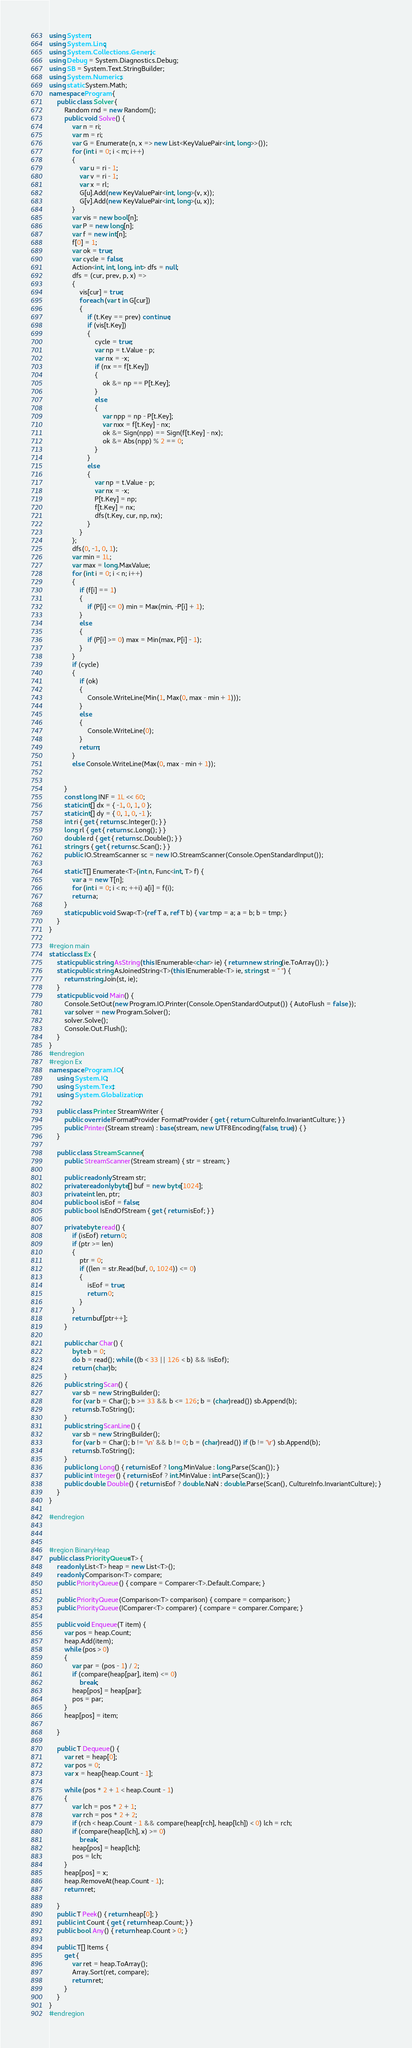<code> <loc_0><loc_0><loc_500><loc_500><_C#_>using System;
using System.Linq;
using System.Collections.Generic;
using Debug = System.Diagnostics.Debug;
using SB = System.Text.StringBuilder;
using System.Numerics;
using static System.Math;
namespace Program {
    public class Solver {
        Random rnd = new Random();
        public void Solve() {
            var n = ri;
            var m = ri;
            var G = Enumerate(n, x => new List<KeyValuePair<int, long>>());
            for (int i = 0; i < m; i++)
            {
                var u = ri - 1;
                var v = ri - 1;
                var x = rl;
                G[u].Add(new KeyValuePair<int, long>(v, x));
                G[v].Add(new KeyValuePair<int, long>(u, x));
            }
            var vis = new bool[n];
            var P = new long[n];
            var f = new int[n];
            f[0] = 1;
            var ok = true;
            var cycle = false;
            Action<int, int, long, int> dfs = null;
            dfs = (cur, prev, p, x) =>
            {
                vis[cur] = true;
                foreach (var t in G[cur])
                {
                    if (t.Key == prev) continue;
                    if (vis[t.Key])
                    {
                        cycle = true;
                        var np = t.Value - p;
                        var nx = -x;
                        if (nx == f[t.Key])
                        {
                            ok &= np == P[t.Key];
                        }
                        else
                        {
                            var npp = np - P[t.Key];
                            var nxx = f[t.Key] - nx;
                            ok &= Sign(npp) == Sign(f[t.Key] - nx);
                            ok &= Abs(npp) % 2 == 0;
                        }
                    }
                    else
                    {
                        var np = t.Value - p;
                        var nx = -x;
                        P[t.Key] = np;
                        f[t.Key] = nx;
                        dfs(t.Key, cur, np, nx);
                    }
                }
            };
            dfs(0, -1, 0, 1);
            var min = 1L;
            var max = long.MaxValue;
            for (int i = 0; i < n; i++)
            {
                if (f[i] == 1)
                {
                    if (P[i] <= 0) min = Max(min, -P[i] + 1);
                }
                else
                {
                    if (P[i] >= 0) max = Min(max, P[i] - 1);
                }
            }
            if (cycle)
            {
                if (ok)
                {
                    Console.WriteLine(Min(1, Max(0, max - min + 1)));
                }
                else
                {
                    Console.WriteLine(0);
                }
                return;
            }
            else Console.WriteLine(Max(0, max - min + 1));


        }
        const long INF = 1L << 60;
        static int[] dx = { -1, 0, 1, 0 };
        static int[] dy = { 0, 1, 0, -1 };
        int ri { get { return sc.Integer(); } }
        long rl { get { return sc.Long(); } }
        double rd { get { return sc.Double(); } }
        string rs { get { return sc.Scan(); } }
        public IO.StreamScanner sc = new IO.StreamScanner(Console.OpenStandardInput());

        static T[] Enumerate<T>(int n, Func<int, T> f) {
            var a = new T[n];
            for (int i = 0; i < n; ++i) a[i] = f(i);
            return a;
        }
        static public void Swap<T>(ref T a, ref T b) { var tmp = a; a = b; b = tmp; }
    }
}

#region main
static class Ex {
    static public string AsString(this IEnumerable<char> ie) { return new string(ie.ToArray()); }
    static public string AsJoinedString<T>(this IEnumerable<T> ie, string st = " ") {
        return string.Join(st, ie);
    }
    static public void Main() {
        Console.SetOut(new Program.IO.Printer(Console.OpenStandardOutput()) { AutoFlush = false });
        var solver = new Program.Solver();
        solver.Solve();
        Console.Out.Flush();
    }
}
#endregion
#region Ex
namespace Program.IO {
    using System.IO;
    using System.Text;
    using System.Globalization;

    public class Printer: StreamWriter {
        public override IFormatProvider FormatProvider { get { return CultureInfo.InvariantCulture; } }
        public Printer(Stream stream) : base(stream, new UTF8Encoding(false, true)) { }
    }

    public class StreamScanner {
        public StreamScanner(Stream stream) { str = stream; }

        public readonly Stream str;
        private readonly byte[] buf = new byte[1024];
        private int len, ptr;
        public bool isEof = false;
        public bool IsEndOfStream { get { return isEof; } }

        private byte read() {
            if (isEof) return 0;
            if (ptr >= len)
            {
                ptr = 0;
                if ((len = str.Read(buf, 0, 1024)) <= 0)
                {
                    isEof = true;
                    return 0;
                }
            }
            return buf[ptr++];
        }

        public char Char() {
            byte b = 0;
            do b = read(); while ((b < 33 || 126 < b) && !isEof);
            return (char)b;
        }
        public string Scan() {
            var sb = new StringBuilder();
            for (var b = Char(); b >= 33 && b <= 126; b = (char)read()) sb.Append(b);
            return sb.ToString();
        }
        public string ScanLine() {
            var sb = new StringBuilder();
            for (var b = Char(); b != '\n' && b != 0; b = (char)read()) if (b != '\r') sb.Append(b);
            return sb.ToString();
        }
        public long Long() { return isEof ? long.MinValue : long.Parse(Scan()); }
        public int Integer() { return isEof ? int.MinValue : int.Parse(Scan()); }
        public double Double() { return isEof ? double.NaN : double.Parse(Scan(), CultureInfo.InvariantCulture); }
    }
}

#endregion



#region BinaryHeap
public class PriorityQueue<T> {
    readonly List<T> heap = new List<T>();
    readonly Comparison<T> compare;
    public PriorityQueue() { compare = Comparer<T>.Default.Compare; }

    public PriorityQueue(Comparison<T> comparison) { compare = comparison; }
    public PriorityQueue(IComparer<T> comparer) { compare = comparer.Compare; }

    public void Enqueue(T item) {
        var pos = heap.Count;
        heap.Add(item);
        while (pos > 0)
        {
            var par = (pos - 1) / 2;
            if (compare(heap[par], item) <= 0)
                break;
            heap[pos] = heap[par];
            pos = par;
        }
        heap[pos] = item;

    }

    public T Dequeue() {
        var ret = heap[0];
        var pos = 0;
        var x = heap[heap.Count - 1];

        while (pos * 2 + 1 < heap.Count - 1)
        {
            var lch = pos * 2 + 1;
            var rch = pos * 2 + 2;
            if (rch < heap.Count - 1 && compare(heap[rch], heap[lch]) < 0) lch = rch;
            if (compare(heap[lch], x) >= 0)
                break;
            heap[pos] = heap[lch];
            pos = lch;
        }
        heap[pos] = x;
        heap.RemoveAt(heap.Count - 1);
        return ret;

    }
    public T Peek() { return heap[0]; }
    public int Count { get { return heap.Count; } }
    public bool Any() { return heap.Count > 0; }

    public T[] Items {
        get {
            var ret = heap.ToArray();
            Array.Sort(ret, compare);
            return ret;
        }
    }
}
#endregion</code> 